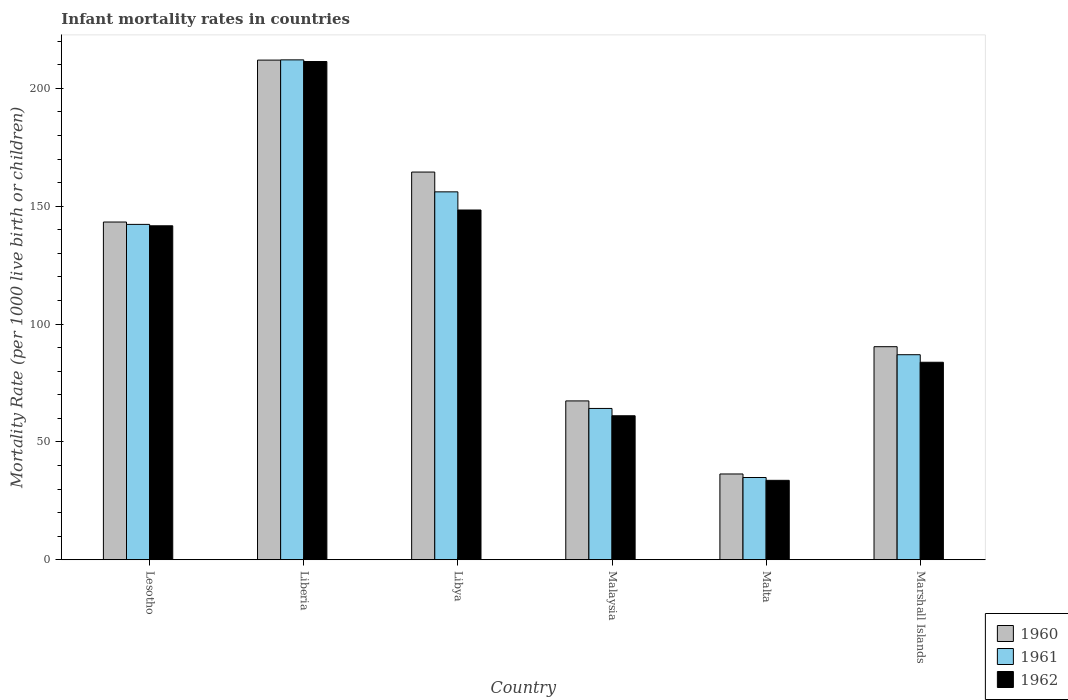How many groups of bars are there?
Offer a terse response. 6. Are the number of bars per tick equal to the number of legend labels?
Keep it short and to the point. Yes. Are the number of bars on each tick of the X-axis equal?
Give a very brief answer. Yes. What is the label of the 3rd group of bars from the left?
Your answer should be compact. Libya. What is the infant mortality rate in 1960 in Liberia?
Make the answer very short. 212. Across all countries, what is the maximum infant mortality rate in 1960?
Offer a very short reply. 212. Across all countries, what is the minimum infant mortality rate in 1962?
Your response must be concise. 33.7. In which country was the infant mortality rate in 1961 maximum?
Keep it short and to the point. Liberia. In which country was the infant mortality rate in 1960 minimum?
Your response must be concise. Malta. What is the total infant mortality rate in 1961 in the graph?
Provide a short and direct response. 696.6. What is the difference between the infant mortality rate in 1960 in Liberia and that in Libya?
Provide a short and direct response. 47.5. What is the difference between the infant mortality rate in 1962 in Liberia and the infant mortality rate in 1961 in Malaysia?
Offer a terse response. 147.2. What is the average infant mortality rate in 1961 per country?
Provide a succinct answer. 116.1. What is the difference between the infant mortality rate of/in 1962 and infant mortality rate of/in 1960 in Malta?
Offer a very short reply. -2.7. What is the ratio of the infant mortality rate in 1962 in Lesotho to that in Malaysia?
Your answer should be compact. 2.32. Is the difference between the infant mortality rate in 1962 in Libya and Marshall Islands greater than the difference between the infant mortality rate in 1960 in Libya and Marshall Islands?
Keep it short and to the point. No. What is the difference between the highest and the second highest infant mortality rate in 1960?
Provide a short and direct response. -47.5. What is the difference between the highest and the lowest infant mortality rate in 1960?
Give a very brief answer. 175.6. Is the sum of the infant mortality rate in 1960 in Malta and Marshall Islands greater than the maximum infant mortality rate in 1962 across all countries?
Ensure brevity in your answer.  No. What does the 2nd bar from the left in Liberia represents?
Your answer should be very brief. 1961. What does the 1st bar from the right in Marshall Islands represents?
Provide a short and direct response. 1962. Are all the bars in the graph horizontal?
Provide a succinct answer. No. How many countries are there in the graph?
Offer a very short reply. 6. What is the difference between two consecutive major ticks on the Y-axis?
Your response must be concise. 50. Are the values on the major ticks of Y-axis written in scientific E-notation?
Make the answer very short. No. Where does the legend appear in the graph?
Keep it short and to the point. Bottom right. How many legend labels are there?
Provide a short and direct response. 3. What is the title of the graph?
Your answer should be very brief. Infant mortality rates in countries. Does "1982" appear as one of the legend labels in the graph?
Your answer should be compact. No. What is the label or title of the X-axis?
Offer a very short reply. Country. What is the label or title of the Y-axis?
Your answer should be compact. Mortality Rate (per 1000 live birth or children). What is the Mortality Rate (per 1000 live birth or children) of 1960 in Lesotho?
Make the answer very short. 143.3. What is the Mortality Rate (per 1000 live birth or children) of 1961 in Lesotho?
Offer a very short reply. 142.3. What is the Mortality Rate (per 1000 live birth or children) of 1962 in Lesotho?
Your answer should be very brief. 141.7. What is the Mortality Rate (per 1000 live birth or children) in 1960 in Liberia?
Give a very brief answer. 212. What is the Mortality Rate (per 1000 live birth or children) of 1961 in Liberia?
Make the answer very short. 212.1. What is the Mortality Rate (per 1000 live birth or children) of 1962 in Liberia?
Provide a short and direct response. 211.4. What is the Mortality Rate (per 1000 live birth or children) of 1960 in Libya?
Provide a short and direct response. 164.5. What is the Mortality Rate (per 1000 live birth or children) of 1961 in Libya?
Ensure brevity in your answer.  156.1. What is the Mortality Rate (per 1000 live birth or children) in 1962 in Libya?
Provide a short and direct response. 148.4. What is the Mortality Rate (per 1000 live birth or children) of 1960 in Malaysia?
Provide a succinct answer. 67.4. What is the Mortality Rate (per 1000 live birth or children) in 1961 in Malaysia?
Ensure brevity in your answer.  64.2. What is the Mortality Rate (per 1000 live birth or children) in 1962 in Malaysia?
Provide a short and direct response. 61.1. What is the Mortality Rate (per 1000 live birth or children) in 1960 in Malta?
Ensure brevity in your answer.  36.4. What is the Mortality Rate (per 1000 live birth or children) of 1961 in Malta?
Provide a short and direct response. 34.9. What is the Mortality Rate (per 1000 live birth or children) of 1962 in Malta?
Make the answer very short. 33.7. What is the Mortality Rate (per 1000 live birth or children) of 1960 in Marshall Islands?
Give a very brief answer. 90.4. What is the Mortality Rate (per 1000 live birth or children) of 1962 in Marshall Islands?
Provide a short and direct response. 83.8. Across all countries, what is the maximum Mortality Rate (per 1000 live birth or children) in 1960?
Provide a short and direct response. 212. Across all countries, what is the maximum Mortality Rate (per 1000 live birth or children) in 1961?
Your response must be concise. 212.1. Across all countries, what is the maximum Mortality Rate (per 1000 live birth or children) of 1962?
Ensure brevity in your answer.  211.4. Across all countries, what is the minimum Mortality Rate (per 1000 live birth or children) in 1960?
Offer a terse response. 36.4. Across all countries, what is the minimum Mortality Rate (per 1000 live birth or children) in 1961?
Provide a succinct answer. 34.9. Across all countries, what is the minimum Mortality Rate (per 1000 live birth or children) of 1962?
Make the answer very short. 33.7. What is the total Mortality Rate (per 1000 live birth or children) in 1960 in the graph?
Your response must be concise. 714. What is the total Mortality Rate (per 1000 live birth or children) of 1961 in the graph?
Your answer should be very brief. 696.6. What is the total Mortality Rate (per 1000 live birth or children) of 1962 in the graph?
Your answer should be compact. 680.1. What is the difference between the Mortality Rate (per 1000 live birth or children) of 1960 in Lesotho and that in Liberia?
Offer a terse response. -68.7. What is the difference between the Mortality Rate (per 1000 live birth or children) in 1961 in Lesotho and that in Liberia?
Offer a terse response. -69.8. What is the difference between the Mortality Rate (per 1000 live birth or children) in 1962 in Lesotho and that in Liberia?
Offer a terse response. -69.7. What is the difference between the Mortality Rate (per 1000 live birth or children) in 1960 in Lesotho and that in Libya?
Make the answer very short. -21.2. What is the difference between the Mortality Rate (per 1000 live birth or children) of 1962 in Lesotho and that in Libya?
Keep it short and to the point. -6.7. What is the difference between the Mortality Rate (per 1000 live birth or children) in 1960 in Lesotho and that in Malaysia?
Your answer should be very brief. 75.9. What is the difference between the Mortality Rate (per 1000 live birth or children) of 1961 in Lesotho and that in Malaysia?
Offer a very short reply. 78.1. What is the difference between the Mortality Rate (per 1000 live birth or children) in 1962 in Lesotho and that in Malaysia?
Provide a short and direct response. 80.6. What is the difference between the Mortality Rate (per 1000 live birth or children) of 1960 in Lesotho and that in Malta?
Ensure brevity in your answer.  106.9. What is the difference between the Mortality Rate (per 1000 live birth or children) in 1961 in Lesotho and that in Malta?
Ensure brevity in your answer.  107.4. What is the difference between the Mortality Rate (per 1000 live birth or children) of 1962 in Lesotho and that in Malta?
Provide a short and direct response. 108. What is the difference between the Mortality Rate (per 1000 live birth or children) in 1960 in Lesotho and that in Marshall Islands?
Keep it short and to the point. 52.9. What is the difference between the Mortality Rate (per 1000 live birth or children) in 1961 in Lesotho and that in Marshall Islands?
Your answer should be very brief. 55.3. What is the difference between the Mortality Rate (per 1000 live birth or children) of 1962 in Lesotho and that in Marshall Islands?
Make the answer very short. 57.9. What is the difference between the Mortality Rate (per 1000 live birth or children) in 1960 in Liberia and that in Libya?
Your response must be concise. 47.5. What is the difference between the Mortality Rate (per 1000 live birth or children) in 1961 in Liberia and that in Libya?
Offer a very short reply. 56. What is the difference between the Mortality Rate (per 1000 live birth or children) in 1962 in Liberia and that in Libya?
Provide a succinct answer. 63. What is the difference between the Mortality Rate (per 1000 live birth or children) of 1960 in Liberia and that in Malaysia?
Provide a short and direct response. 144.6. What is the difference between the Mortality Rate (per 1000 live birth or children) in 1961 in Liberia and that in Malaysia?
Offer a very short reply. 147.9. What is the difference between the Mortality Rate (per 1000 live birth or children) in 1962 in Liberia and that in Malaysia?
Offer a very short reply. 150.3. What is the difference between the Mortality Rate (per 1000 live birth or children) in 1960 in Liberia and that in Malta?
Your response must be concise. 175.6. What is the difference between the Mortality Rate (per 1000 live birth or children) in 1961 in Liberia and that in Malta?
Offer a terse response. 177.2. What is the difference between the Mortality Rate (per 1000 live birth or children) in 1962 in Liberia and that in Malta?
Your answer should be compact. 177.7. What is the difference between the Mortality Rate (per 1000 live birth or children) of 1960 in Liberia and that in Marshall Islands?
Make the answer very short. 121.6. What is the difference between the Mortality Rate (per 1000 live birth or children) of 1961 in Liberia and that in Marshall Islands?
Provide a succinct answer. 125.1. What is the difference between the Mortality Rate (per 1000 live birth or children) in 1962 in Liberia and that in Marshall Islands?
Provide a short and direct response. 127.6. What is the difference between the Mortality Rate (per 1000 live birth or children) of 1960 in Libya and that in Malaysia?
Keep it short and to the point. 97.1. What is the difference between the Mortality Rate (per 1000 live birth or children) in 1961 in Libya and that in Malaysia?
Your answer should be compact. 91.9. What is the difference between the Mortality Rate (per 1000 live birth or children) in 1962 in Libya and that in Malaysia?
Offer a terse response. 87.3. What is the difference between the Mortality Rate (per 1000 live birth or children) in 1960 in Libya and that in Malta?
Your answer should be very brief. 128.1. What is the difference between the Mortality Rate (per 1000 live birth or children) in 1961 in Libya and that in Malta?
Ensure brevity in your answer.  121.2. What is the difference between the Mortality Rate (per 1000 live birth or children) in 1962 in Libya and that in Malta?
Provide a succinct answer. 114.7. What is the difference between the Mortality Rate (per 1000 live birth or children) in 1960 in Libya and that in Marshall Islands?
Give a very brief answer. 74.1. What is the difference between the Mortality Rate (per 1000 live birth or children) in 1961 in Libya and that in Marshall Islands?
Your answer should be compact. 69.1. What is the difference between the Mortality Rate (per 1000 live birth or children) in 1962 in Libya and that in Marshall Islands?
Your answer should be very brief. 64.6. What is the difference between the Mortality Rate (per 1000 live birth or children) of 1960 in Malaysia and that in Malta?
Offer a very short reply. 31. What is the difference between the Mortality Rate (per 1000 live birth or children) of 1961 in Malaysia and that in Malta?
Provide a short and direct response. 29.3. What is the difference between the Mortality Rate (per 1000 live birth or children) in 1962 in Malaysia and that in Malta?
Ensure brevity in your answer.  27.4. What is the difference between the Mortality Rate (per 1000 live birth or children) in 1960 in Malaysia and that in Marshall Islands?
Offer a terse response. -23. What is the difference between the Mortality Rate (per 1000 live birth or children) of 1961 in Malaysia and that in Marshall Islands?
Your response must be concise. -22.8. What is the difference between the Mortality Rate (per 1000 live birth or children) of 1962 in Malaysia and that in Marshall Islands?
Your response must be concise. -22.7. What is the difference between the Mortality Rate (per 1000 live birth or children) of 1960 in Malta and that in Marshall Islands?
Keep it short and to the point. -54. What is the difference between the Mortality Rate (per 1000 live birth or children) in 1961 in Malta and that in Marshall Islands?
Keep it short and to the point. -52.1. What is the difference between the Mortality Rate (per 1000 live birth or children) of 1962 in Malta and that in Marshall Islands?
Provide a short and direct response. -50.1. What is the difference between the Mortality Rate (per 1000 live birth or children) in 1960 in Lesotho and the Mortality Rate (per 1000 live birth or children) in 1961 in Liberia?
Your answer should be compact. -68.8. What is the difference between the Mortality Rate (per 1000 live birth or children) of 1960 in Lesotho and the Mortality Rate (per 1000 live birth or children) of 1962 in Liberia?
Offer a terse response. -68.1. What is the difference between the Mortality Rate (per 1000 live birth or children) of 1961 in Lesotho and the Mortality Rate (per 1000 live birth or children) of 1962 in Liberia?
Provide a succinct answer. -69.1. What is the difference between the Mortality Rate (per 1000 live birth or children) of 1960 in Lesotho and the Mortality Rate (per 1000 live birth or children) of 1962 in Libya?
Keep it short and to the point. -5.1. What is the difference between the Mortality Rate (per 1000 live birth or children) in 1961 in Lesotho and the Mortality Rate (per 1000 live birth or children) in 1962 in Libya?
Provide a short and direct response. -6.1. What is the difference between the Mortality Rate (per 1000 live birth or children) of 1960 in Lesotho and the Mortality Rate (per 1000 live birth or children) of 1961 in Malaysia?
Offer a very short reply. 79.1. What is the difference between the Mortality Rate (per 1000 live birth or children) in 1960 in Lesotho and the Mortality Rate (per 1000 live birth or children) in 1962 in Malaysia?
Make the answer very short. 82.2. What is the difference between the Mortality Rate (per 1000 live birth or children) of 1961 in Lesotho and the Mortality Rate (per 1000 live birth or children) of 1962 in Malaysia?
Your answer should be compact. 81.2. What is the difference between the Mortality Rate (per 1000 live birth or children) in 1960 in Lesotho and the Mortality Rate (per 1000 live birth or children) in 1961 in Malta?
Keep it short and to the point. 108.4. What is the difference between the Mortality Rate (per 1000 live birth or children) of 1960 in Lesotho and the Mortality Rate (per 1000 live birth or children) of 1962 in Malta?
Your answer should be compact. 109.6. What is the difference between the Mortality Rate (per 1000 live birth or children) of 1961 in Lesotho and the Mortality Rate (per 1000 live birth or children) of 1962 in Malta?
Your response must be concise. 108.6. What is the difference between the Mortality Rate (per 1000 live birth or children) in 1960 in Lesotho and the Mortality Rate (per 1000 live birth or children) in 1961 in Marshall Islands?
Your answer should be very brief. 56.3. What is the difference between the Mortality Rate (per 1000 live birth or children) of 1960 in Lesotho and the Mortality Rate (per 1000 live birth or children) of 1962 in Marshall Islands?
Offer a very short reply. 59.5. What is the difference between the Mortality Rate (per 1000 live birth or children) in 1961 in Lesotho and the Mortality Rate (per 1000 live birth or children) in 1962 in Marshall Islands?
Your response must be concise. 58.5. What is the difference between the Mortality Rate (per 1000 live birth or children) of 1960 in Liberia and the Mortality Rate (per 1000 live birth or children) of 1961 in Libya?
Your response must be concise. 55.9. What is the difference between the Mortality Rate (per 1000 live birth or children) in 1960 in Liberia and the Mortality Rate (per 1000 live birth or children) in 1962 in Libya?
Your answer should be very brief. 63.6. What is the difference between the Mortality Rate (per 1000 live birth or children) in 1961 in Liberia and the Mortality Rate (per 1000 live birth or children) in 1962 in Libya?
Offer a very short reply. 63.7. What is the difference between the Mortality Rate (per 1000 live birth or children) of 1960 in Liberia and the Mortality Rate (per 1000 live birth or children) of 1961 in Malaysia?
Provide a short and direct response. 147.8. What is the difference between the Mortality Rate (per 1000 live birth or children) in 1960 in Liberia and the Mortality Rate (per 1000 live birth or children) in 1962 in Malaysia?
Keep it short and to the point. 150.9. What is the difference between the Mortality Rate (per 1000 live birth or children) of 1961 in Liberia and the Mortality Rate (per 1000 live birth or children) of 1962 in Malaysia?
Provide a short and direct response. 151. What is the difference between the Mortality Rate (per 1000 live birth or children) of 1960 in Liberia and the Mortality Rate (per 1000 live birth or children) of 1961 in Malta?
Your answer should be compact. 177.1. What is the difference between the Mortality Rate (per 1000 live birth or children) in 1960 in Liberia and the Mortality Rate (per 1000 live birth or children) in 1962 in Malta?
Provide a succinct answer. 178.3. What is the difference between the Mortality Rate (per 1000 live birth or children) of 1961 in Liberia and the Mortality Rate (per 1000 live birth or children) of 1962 in Malta?
Provide a short and direct response. 178.4. What is the difference between the Mortality Rate (per 1000 live birth or children) of 1960 in Liberia and the Mortality Rate (per 1000 live birth or children) of 1961 in Marshall Islands?
Offer a very short reply. 125. What is the difference between the Mortality Rate (per 1000 live birth or children) of 1960 in Liberia and the Mortality Rate (per 1000 live birth or children) of 1962 in Marshall Islands?
Your answer should be compact. 128.2. What is the difference between the Mortality Rate (per 1000 live birth or children) of 1961 in Liberia and the Mortality Rate (per 1000 live birth or children) of 1962 in Marshall Islands?
Keep it short and to the point. 128.3. What is the difference between the Mortality Rate (per 1000 live birth or children) of 1960 in Libya and the Mortality Rate (per 1000 live birth or children) of 1961 in Malaysia?
Make the answer very short. 100.3. What is the difference between the Mortality Rate (per 1000 live birth or children) in 1960 in Libya and the Mortality Rate (per 1000 live birth or children) in 1962 in Malaysia?
Give a very brief answer. 103.4. What is the difference between the Mortality Rate (per 1000 live birth or children) in 1960 in Libya and the Mortality Rate (per 1000 live birth or children) in 1961 in Malta?
Your answer should be very brief. 129.6. What is the difference between the Mortality Rate (per 1000 live birth or children) in 1960 in Libya and the Mortality Rate (per 1000 live birth or children) in 1962 in Malta?
Offer a terse response. 130.8. What is the difference between the Mortality Rate (per 1000 live birth or children) in 1961 in Libya and the Mortality Rate (per 1000 live birth or children) in 1962 in Malta?
Provide a short and direct response. 122.4. What is the difference between the Mortality Rate (per 1000 live birth or children) of 1960 in Libya and the Mortality Rate (per 1000 live birth or children) of 1961 in Marshall Islands?
Keep it short and to the point. 77.5. What is the difference between the Mortality Rate (per 1000 live birth or children) of 1960 in Libya and the Mortality Rate (per 1000 live birth or children) of 1962 in Marshall Islands?
Your answer should be compact. 80.7. What is the difference between the Mortality Rate (per 1000 live birth or children) in 1961 in Libya and the Mortality Rate (per 1000 live birth or children) in 1962 in Marshall Islands?
Your answer should be very brief. 72.3. What is the difference between the Mortality Rate (per 1000 live birth or children) of 1960 in Malaysia and the Mortality Rate (per 1000 live birth or children) of 1961 in Malta?
Offer a terse response. 32.5. What is the difference between the Mortality Rate (per 1000 live birth or children) in 1960 in Malaysia and the Mortality Rate (per 1000 live birth or children) in 1962 in Malta?
Your answer should be compact. 33.7. What is the difference between the Mortality Rate (per 1000 live birth or children) in 1961 in Malaysia and the Mortality Rate (per 1000 live birth or children) in 1962 in Malta?
Provide a succinct answer. 30.5. What is the difference between the Mortality Rate (per 1000 live birth or children) in 1960 in Malaysia and the Mortality Rate (per 1000 live birth or children) in 1961 in Marshall Islands?
Offer a very short reply. -19.6. What is the difference between the Mortality Rate (per 1000 live birth or children) in 1960 in Malaysia and the Mortality Rate (per 1000 live birth or children) in 1962 in Marshall Islands?
Offer a terse response. -16.4. What is the difference between the Mortality Rate (per 1000 live birth or children) in 1961 in Malaysia and the Mortality Rate (per 1000 live birth or children) in 1962 in Marshall Islands?
Offer a very short reply. -19.6. What is the difference between the Mortality Rate (per 1000 live birth or children) in 1960 in Malta and the Mortality Rate (per 1000 live birth or children) in 1961 in Marshall Islands?
Your response must be concise. -50.6. What is the difference between the Mortality Rate (per 1000 live birth or children) in 1960 in Malta and the Mortality Rate (per 1000 live birth or children) in 1962 in Marshall Islands?
Give a very brief answer. -47.4. What is the difference between the Mortality Rate (per 1000 live birth or children) in 1961 in Malta and the Mortality Rate (per 1000 live birth or children) in 1962 in Marshall Islands?
Keep it short and to the point. -48.9. What is the average Mortality Rate (per 1000 live birth or children) of 1960 per country?
Provide a succinct answer. 119. What is the average Mortality Rate (per 1000 live birth or children) of 1961 per country?
Offer a terse response. 116.1. What is the average Mortality Rate (per 1000 live birth or children) in 1962 per country?
Give a very brief answer. 113.35. What is the difference between the Mortality Rate (per 1000 live birth or children) in 1960 and Mortality Rate (per 1000 live birth or children) in 1961 in Lesotho?
Keep it short and to the point. 1. What is the difference between the Mortality Rate (per 1000 live birth or children) in 1960 and Mortality Rate (per 1000 live birth or children) in 1962 in Lesotho?
Offer a very short reply. 1.6. What is the difference between the Mortality Rate (per 1000 live birth or children) in 1961 and Mortality Rate (per 1000 live birth or children) in 1962 in Lesotho?
Your response must be concise. 0.6. What is the difference between the Mortality Rate (per 1000 live birth or children) of 1960 and Mortality Rate (per 1000 live birth or children) of 1961 in Libya?
Provide a short and direct response. 8.4. What is the difference between the Mortality Rate (per 1000 live birth or children) of 1960 and Mortality Rate (per 1000 live birth or children) of 1962 in Libya?
Make the answer very short. 16.1. What is the difference between the Mortality Rate (per 1000 live birth or children) in 1960 and Mortality Rate (per 1000 live birth or children) in 1961 in Malaysia?
Offer a terse response. 3.2. What is the difference between the Mortality Rate (per 1000 live birth or children) in 1960 and Mortality Rate (per 1000 live birth or children) in 1962 in Malaysia?
Your response must be concise. 6.3. What is the difference between the Mortality Rate (per 1000 live birth or children) in 1961 and Mortality Rate (per 1000 live birth or children) in 1962 in Malaysia?
Your answer should be very brief. 3.1. What is the difference between the Mortality Rate (per 1000 live birth or children) of 1960 and Mortality Rate (per 1000 live birth or children) of 1962 in Marshall Islands?
Your answer should be compact. 6.6. What is the difference between the Mortality Rate (per 1000 live birth or children) in 1961 and Mortality Rate (per 1000 live birth or children) in 1962 in Marshall Islands?
Keep it short and to the point. 3.2. What is the ratio of the Mortality Rate (per 1000 live birth or children) of 1960 in Lesotho to that in Liberia?
Provide a short and direct response. 0.68. What is the ratio of the Mortality Rate (per 1000 live birth or children) in 1961 in Lesotho to that in Liberia?
Provide a succinct answer. 0.67. What is the ratio of the Mortality Rate (per 1000 live birth or children) of 1962 in Lesotho to that in Liberia?
Offer a very short reply. 0.67. What is the ratio of the Mortality Rate (per 1000 live birth or children) of 1960 in Lesotho to that in Libya?
Your response must be concise. 0.87. What is the ratio of the Mortality Rate (per 1000 live birth or children) in 1961 in Lesotho to that in Libya?
Your response must be concise. 0.91. What is the ratio of the Mortality Rate (per 1000 live birth or children) in 1962 in Lesotho to that in Libya?
Provide a short and direct response. 0.95. What is the ratio of the Mortality Rate (per 1000 live birth or children) in 1960 in Lesotho to that in Malaysia?
Offer a very short reply. 2.13. What is the ratio of the Mortality Rate (per 1000 live birth or children) in 1961 in Lesotho to that in Malaysia?
Ensure brevity in your answer.  2.22. What is the ratio of the Mortality Rate (per 1000 live birth or children) of 1962 in Lesotho to that in Malaysia?
Provide a succinct answer. 2.32. What is the ratio of the Mortality Rate (per 1000 live birth or children) of 1960 in Lesotho to that in Malta?
Make the answer very short. 3.94. What is the ratio of the Mortality Rate (per 1000 live birth or children) of 1961 in Lesotho to that in Malta?
Your answer should be compact. 4.08. What is the ratio of the Mortality Rate (per 1000 live birth or children) in 1962 in Lesotho to that in Malta?
Offer a terse response. 4.2. What is the ratio of the Mortality Rate (per 1000 live birth or children) of 1960 in Lesotho to that in Marshall Islands?
Offer a very short reply. 1.59. What is the ratio of the Mortality Rate (per 1000 live birth or children) of 1961 in Lesotho to that in Marshall Islands?
Provide a succinct answer. 1.64. What is the ratio of the Mortality Rate (per 1000 live birth or children) of 1962 in Lesotho to that in Marshall Islands?
Provide a succinct answer. 1.69. What is the ratio of the Mortality Rate (per 1000 live birth or children) in 1960 in Liberia to that in Libya?
Offer a terse response. 1.29. What is the ratio of the Mortality Rate (per 1000 live birth or children) of 1961 in Liberia to that in Libya?
Provide a short and direct response. 1.36. What is the ratio of the Mortality Rate (per 1000 live birth or children) of 1962 in Liberia to that in Libya?
Keep it short and to the point. 1.42. What is the ratio of the Mortality Rate (per 1000 live birth or children) in 1960 in Liberia to that in Malaysia?
Your answer should be compact. 3.15. What is the ratio of the Mortality Rate (per 1000 live birth or children) in 1961 in Liberia to that in Malaysia?
Offer a very short reply. 3.3. What is the ratio of the Mortality Rate (per 1000 live birth or children) in 1962 in Liberia to that in Malaysia?
Provide a succinct answer. 3.46. What is the ratio of the Mortality Rate (per 1000 live birth or children) in 1960 in Liberia to that in Malta?
Give a very brief answer. 5.82. What is the ratio of the Mortality Rate (per 1000 live birth or children) in 1961 in Liberia to that in Malta?
Your answer should be compact. 6.08. What is the ratio of the Mortality Rate (per 1000 live birth or children) of 1962 in Liberia to that in Malta?
Provide a short and direct response. 6.27. What is the ratio of the Mortality Rate (per 1000 live birth or children) in 1960 in Liberia to that in Marshall Islands?
Your answer should be very brief. 2.35. What is the ratio of the Mortality Rate (per 1000 live birth or children) in 1961 in Liberia to that in Marshall Islands?
Ensure brevity in your answer.  2.44. What is the ratio of the Mortality Rate (per 1000 live birth or children) in 1962 in Liberia to that in Marshall Islands?
Offer a very short reply. 2.52. What is the ratio of the Mortality Rate (per 1000 live birth or children) of 1960 in Libya to that in Malaysia?
Offer a very short reply. 2.44. What is the ratio of the Mortality Rate (per 1000 live birth or children) of 1961 in Libya to that in Malaysia?
Provide a succinct answer. 2.43. What is the ratio of the Mortality Rate (per 1000 live birth or children) in 1962 in Libya to that in Malaysia?
Ensure brevity in your answer.  2.43. What is the ratio of the Mortality Rate (per 1000 live birth or children) in 1960 in Libya to that in Malta?
Give a very brief answer. 4.52. What is the ratio of the Mortality Rate (per 1000 live birth or children) in 1961 in Libya to that in Malta?
Your response must be concise. 4.47. What is the ratio of the Mortality Rate (per 1000 live birth or children) in 1962 in Libya to that in Malta?
Offer a very short reply. 4.4. What is the ratio of the Mortality Rate (per 1000 live birth or children) in 1960 in Libya to that in Marshall Islands?
Provide a succinct answer. 1.82. What is the ratio of the Mortality Rate (per 1000 live birth or children) of 1961 in Libya to that in Marshall Islands?
Ensure brevity in your answer.  1.79. What is the ratio of the Mortality Rate (per 1000 live birth or children) of 1962 in Libya to that in Marshall Islands?
Make the answer very short. 1.77. What is the ratio of the Mortality Rate (per 1000 live birth or children) of 1960 in Malaysia to that in Malta?
Keep it short and to the point. 1.85. What is the ratio of the Mortality Rate (per 1000 live birth or children) of 1961 in Malaysia to that in Malta?
Keep it short and to the point. 1.84. What is the ratio of the Mortality Rate (per 1000 live birth or children) in 1962 in Malaysia to that in Malta?
Provide a succinct answer. 1.81. What is the ratio of the Mortality Rate (per 1000 live birth or children) in 1960 in Malaysia to that in Marshall Islands?
Provide a succinct answer. 0.75. What is the ratio of the Mortality Rate (per 1000 live birth or children) of 1961 in Malaysia to that in Marshall Islands?
Provide a succinct answer. 0.74. What is the ratio of the Mortality Rate (per 1000 live birth or children) in 1962 in Malaysia to that in Marshall Islands?
Offer a terse response. 0.73. What is the ratio of the Mortality Rate (per 1000 live birth or children) of 1960 in Malta to that in Marshall Islands?
Offer a terse response. 0.4. What is the ratio of the Mortality Rate (per 1000 live birth or children) in 1961 in Malta to that in Marshall Islands?
Your answer should be very brief. 0.4. What is the ratio of the Mortality Rate (per 1000 live birth or children) in 1962 in Malta to that in Marshall Islands?
Your response must be concise. 0.4. What is the difference between the highest and the second highest Mortality Rate (per 1000 live birth or children) in 1960?
Give a very brief answer. 47.5. What is the difference between the highest and the second highest Mortality Rate (per 1000 live birth or children) in 1962?
Provide a short and direct response. 63. What is the difference between the highest and the lowest Mortality Rate (per 1000 live birth or children) of 1960?
Make the answer very short. 175.6. What is the difference between the highest and the lowest Mortality Rate (per 1000 live birth or children) of 1961?
Keep it short and to the point. 177.2. What is the difference between the highest and the lowest Mortality Rate (per 1000 live birth or children) of 1962?
Provide a short and direct response. 177.7. 